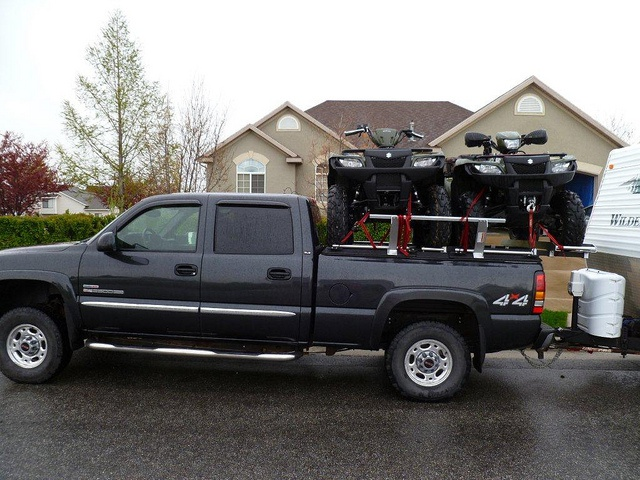Describe the objects in this image and their specific colors. I can see a truck in white, black, gray, and darkgray tones in this image. 